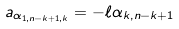<formula> <loc_0><loc_0><loc_500><loc_500>a _ { \alpha _ { 1 , n - k + 1 , k } } = - \ell \alpha _ { k , n - k + 1 }</formula> 